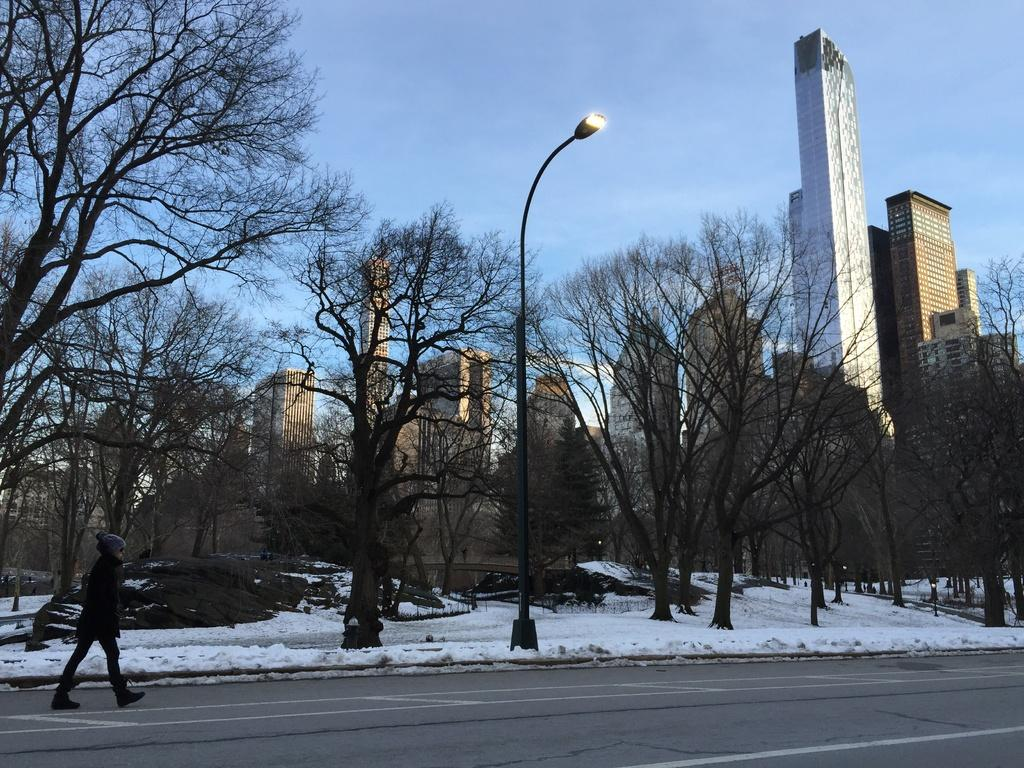What is the person in the image doing? There is a person walking on the road in the image. What is the weather like in the image? There is snow in the image, indicating a cold and wintry scene. What can be seen in the background of the image? There are trees, a pole, and buildings in the background. How many pizzas is the manager holding in the image? There are no pizzas or managers present in the image. What type of ear is visible on the person walking on the road? There is no ear visible on the person walking on the road in the image. 